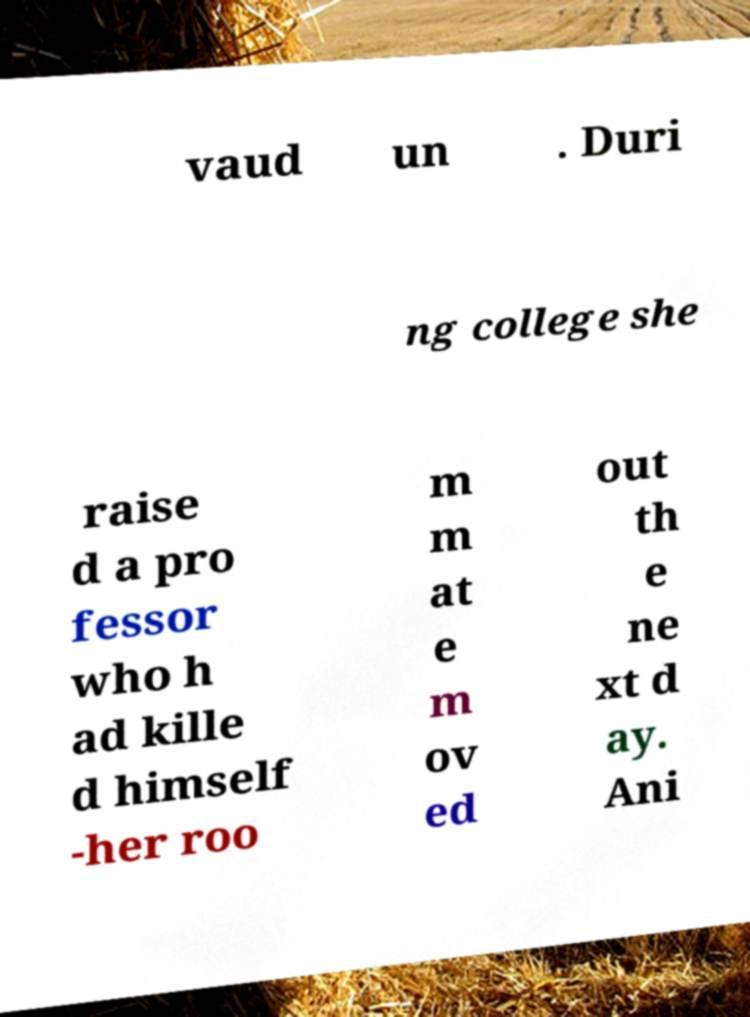For documentation purposes, I need the text within this image transcribed. Could you provide that? vaud un . Duri ng college she raise d a pro fessor who h ad kille d himself -her roo m m at e m ov ed out th e ne xt d ay. Ani 